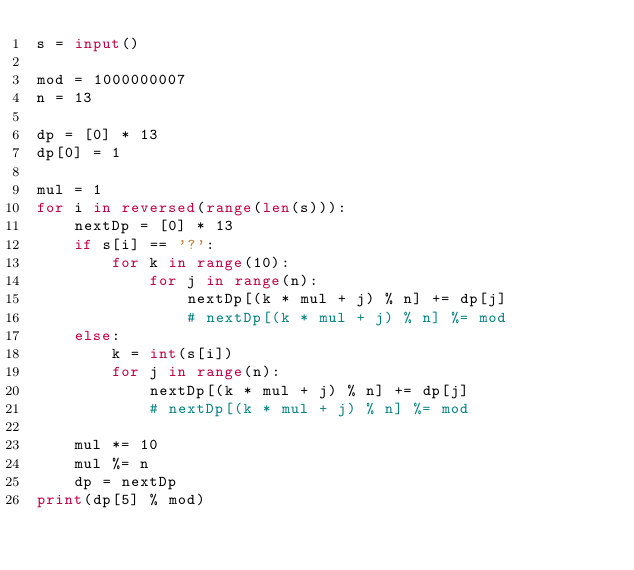Convert code to text. <code><loc_0><loc_0><loc_500><loc_500><_Python_>s = input()

mod = 1000000007
n = 13

dp = [0] * 13
dp[0] = 1

mul = 1
for i in reversed(range(len(s))):
    nextDp = [0] * 13
    if s[i] == '?':
        for k in range(10):
            for j in range(n):
                nextDp[(k * mul + j) % n] += dp[j]
                # nextDp[(k * mul + j) % n] %= mod
    else:
        k = int(s[i])
        for j in range(n):
            nextDp[(k * mul + j) % n] += dp[j]
            # nextDp[(k * mul + j) % n] %= mod

    mul *= 10
    mul %= n
    dp = nextDp
print(dp[5] % mod)
</code> 